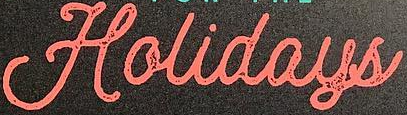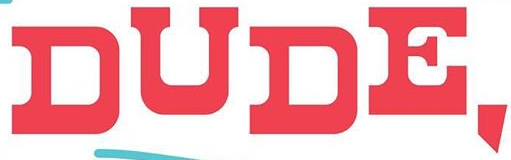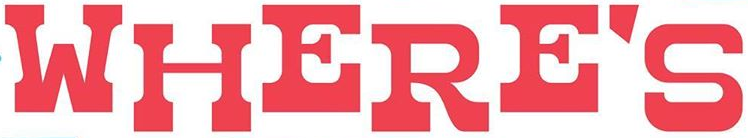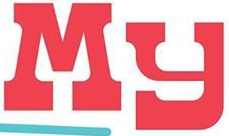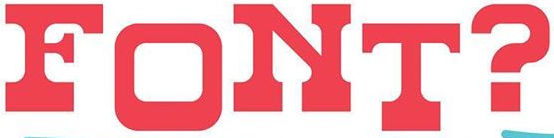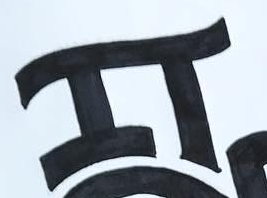What text is displayed in these images sequentially, separated by a semicolon? Holidays; DUDE,; WHERE'S; My; FONT?; IT 